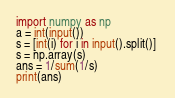Convert code to text. <code><loc_0><loc_0><loc_500><loc_500><_Python_>import numpy as np
a = int(input())
s = [int(i) for i in input().split()] 
s = np.array(s)
ans = 1/sum(1/s)
print(ans)</code> 